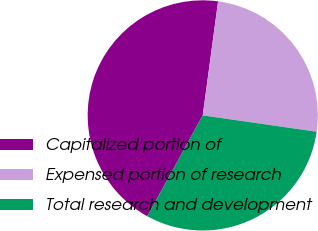Convert chart. <chart><loc_0><loc_0><loc_500><loc_500><pie_chart><fcel>Capitalized portion of<fcel>Expensed portion of research<fcel>Total research and development<nl><fcel>44.13%<fcel>25.14%<fcel>30.73%<nl></chart> 